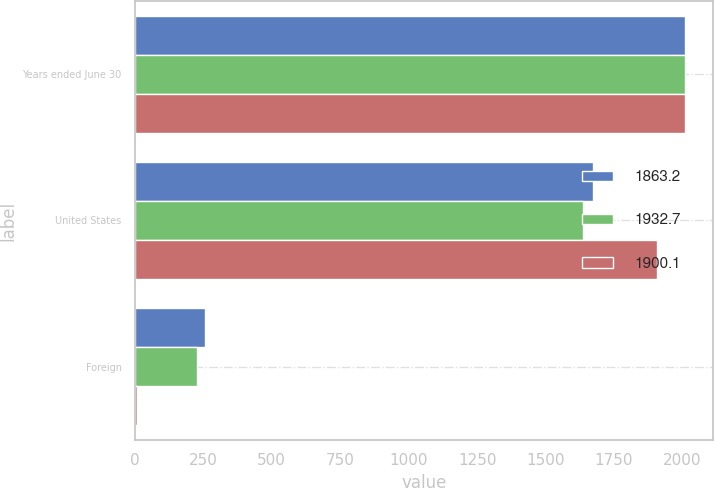Convert chart. <chart><loc_0><loc_0><loc_500><loc_500><stacked_bar_chart><ecel><fcel>Years ended June 30<fcel>United States<fcel>Foreign<nl><fcel>1863.2<fcel>2011<fcel>1675.1<fcel>257.6<nl><fcel>1932.7<fcel>2010<fcel>1638<fcel>225.2<nl><fcel>1900.1<fcel>2009<fcel>1908.6<fcel>8.5<nl></chart> 